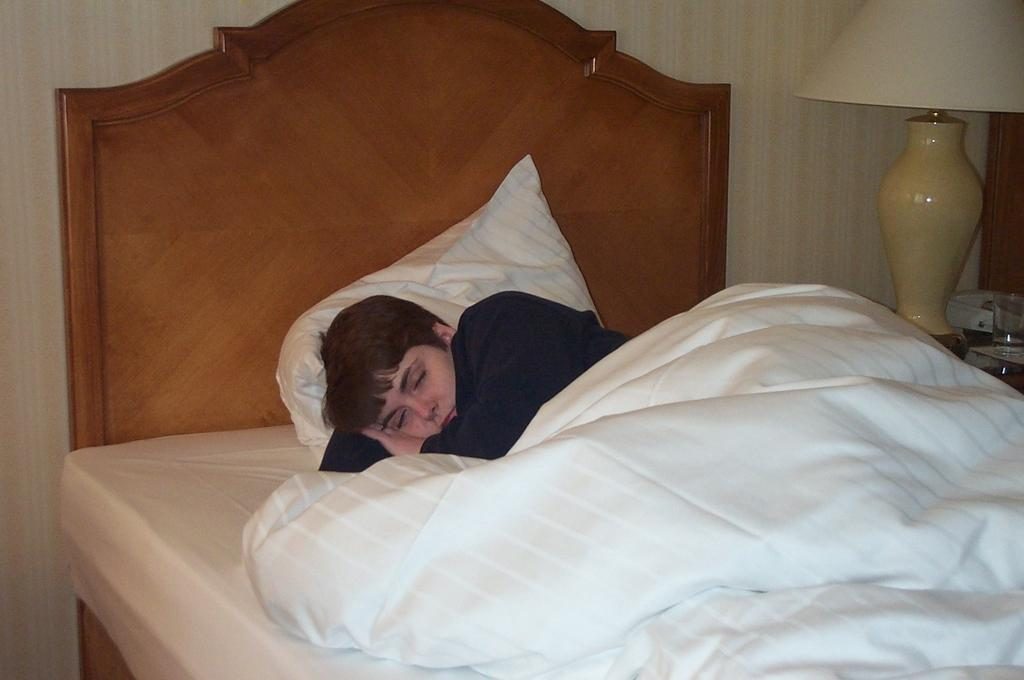What is the main subject of the image? There is a kid in the image. What is the kid doing in the image? The kid is sleeping. What color is the bed in the image? The bed is white. What object is located beside the kid? There is a lamp beside the kid. How does the kid twist around on the swing in the image? There is no swing present in the image; the kid is sleeping on a white bed. 